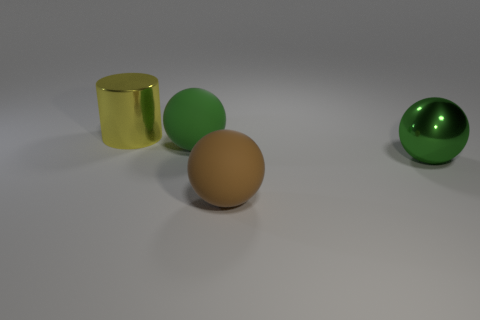Subtract all red cylinders. Subtract all brown cubes. How many cylinders are left? 1 Add 1 tiny blocks. How many objects exist? 5 Subtract all spheres. How many objects are left? 1 Add 4 large things. How many large things exist? 8 Subtract 0 gray spheres. How many objects are left? 4 Subtract all small blue spheres. Subtract all big rubber things. How many objects are left? 2 Add 3 large matte things. How many large matte things are left? 5 